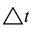<formula> <loc_0><loc_0><loc_500><loc_500>\bigtriangleup t</formula> 